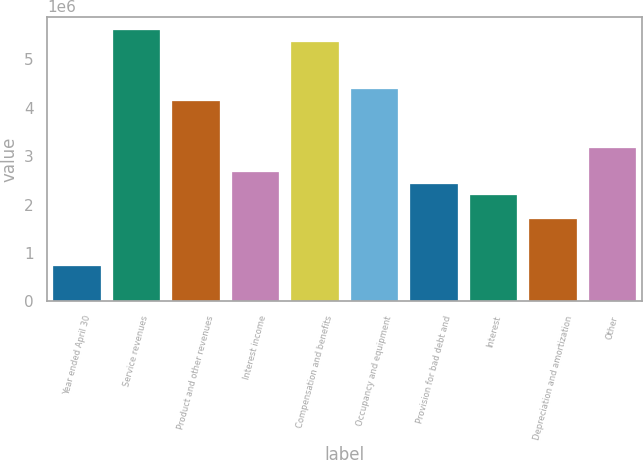<chart> <loc_0><loc_0><loc_500><loc_500><bar_chart><fcel>Year ended April 30<fcel>Service revenues<fcel>Product and other revenues<fcel>Interest income<fcel>Compensation and benefits<fcel>Occupancy and equipment<fcel>Provision for bad debt and<fcel>Interest<fcel>Depreciation and amortization<fcel>Other<nl><fcel>730293<fcel>5.5989e+06<fcel>4.13832e+06<fcel>2.67774e+06<fcel>5.35547e+06<fcel>4.38175e+06<fcel>2.43431e+06<fcel>2.19088e+06<fcel>1.70402e+06<fcel>3.1646e+06<nl></chart> 